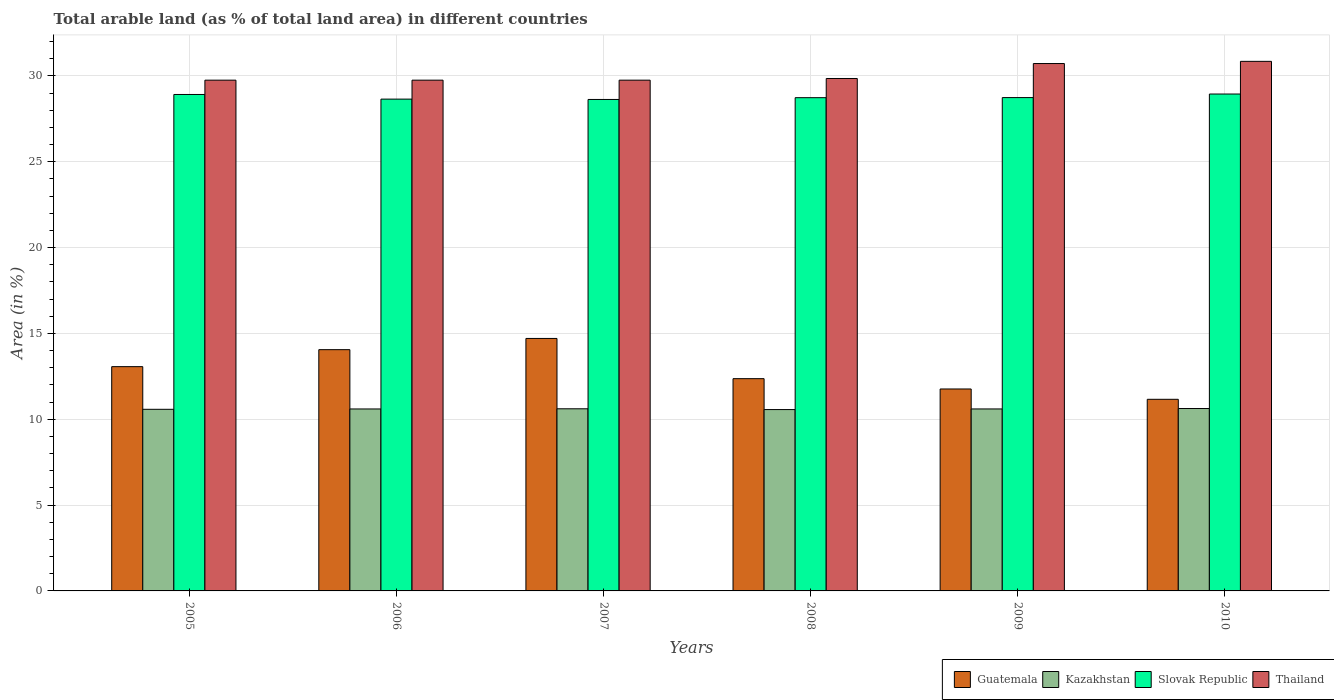Are the number of bars per tick equal to the number of legend labels?
Ensure brevity in your answer.  Yes. Are the number of bars on each tick of the X-axis equal?
Give a very brief answer. Yes. How many bars are there on the 2nd tick from the left?
Offer a terse response. 4. How many bars are there on the 4th tick from the right?
Make the answer very short. 4. What is the label of the 2nd group of bars from the left?
Your response must be concise. 2006. What is the percentage of arable land in Kazakhstan in 2008?
Your response must be concise. 10.56. Across all years, what is the maximum percentage of arable land in Thailand?
Offer a very short reply. 30.85. Across all years, what is the minimum percentage of arable land in Kazakhstan?
Keep it short and to the point. 10.56. In which year was the percentage of arable land in Kazakhstan minimum?
Ensure brevity in your answer.  2008. What is the total percentage of arable land in Slovak Republic in the graph?
Make the answer very short. 172.61. What is the difference between the percentage of arable land in Kazakhstan in 2008 and that in 2009?
Your answer should be very brief. -0.04. What is the difference between the percentage of arable land in Thailand in 2008 and the percentage of arable land in Slovak Republic in 2009?
Make the answer very short. 1.11. What is the average percentage of arable land in Slovak Republic per year?
Offer a very short reply. 28.77. In the year 2005, what is the difference between the percentage of arable land in Thailand and percentage of arable land in Kazakhstan?
Keep it short and to the point. 19.17. In how many years, is the percentage of arable land in Slovak Republic greater than 4 %?
Provide a succinct answer. 6. What is the ratio of the percentage of arable land in Thailand in 2007 to that in 2009?
Ensure brevity in your answer.  0.97. Is the difference between the percentage of arable land in Thailand in 2005 and 2007 greater than the difference between the percentage of arable land in Kazakhstan in 2005 and 2007?
Offer a very short reply. Yes. What is the difference between the highest and the second highest percentage of arable land in Kazakhstan?
Provide a short and direct response. 0.02. What is the difference between the highest and the lowest percentage of arable land in Thailand?
Provide a short and direct response. 1.1. In how many years, is the percentage of arable land in Kazakhstan greater than the average percentage of arable land in Kazakhstan taken over all years?
Give a very brief answer. 4. Is the sum of the percentage of arable land in Thailand in 2006 and 2008 greater than the maximum percentage of arable land in Slovak Republic across all years?
Provide a short and direct response. Yes. What does the 2nd bar from the left in 2007 represents?
Offer a very short reply. Kazakhstan. What does the 2nd bar from the right in 2006 represents?
Ensure brevity in your answer.  Slovak Republic. Are the values on the major ticks of Y-axis written in scientific E-notation?
Offer a very short reply. No. Does the graph contain grids?
Provide a short and direct response. Yes. Where does the legend appear in the graph?
Provide a short and direct response. Bottom right. How are the legend labels stacked?
Give a very brief answer. Horizontal. What is the title of the graph?
Give a very brief answer. Total arable land (as % of total land area) in different countries. Does "Fragile and conflict affected situations" appear as one of the legend labels in the graph?
Provide a succinct answer. No. What is the label or title of the Y-axis?
Ensure brevity in your answer.  Area (in %). What is the Area (in %) in Guatemala in 2005?
Your answer should be very brief. 13.06. What is the Area (in %) in Kazakhstan in 2005?
Offer a terse response. 10.58. What is the Area (in %) in Slovak Republic in 2005?
Offer a very short reply. 28.92. What is the Area (in %) of Thailand in 2005?
Your answer should be compact. 29.75. What is the Area (in %) in Guatemala in 2006?
Make the answer very short. 14.05. What is the Area (in %) of Kazakhstan in 2006?
Your response must be concise. 10.6. What is the Area (in %) of Slovak Republic in 2006?
Give a very brief answer. 28.65. What is the Area (in %) of Thailand in 2006?
Your answer should be compact. 29.75. What is the Area (in %) of Guatemala in 2007?
Offer a terse response. 14.71. What is the Area (in %) in Kazakhstan in 2007?
Your answer should be very brief. 10.61. What is the Area (in %) in Slovak Republic in 2007?
Your response must be concise. 28.63. What is the Area (in %) of Thailand in 2007?
Give a very brief answer. 29.75. What is the Area (in %) of Guatemala in 2008?
Make the answer very short. 12.36. What is the Area (in %) of Kazakhstan in 2008?
Ensure brevity in your answer.  10.56. What is the Area (in %) of Slovak Republic in 2008?
Give a very brief answer. 28.73. What is the Area (in %) in Thailand in 2008?
Keep it short and to the point. 29.85. What is the Area (in %) in Guatemala in 2009?
Offer a very short reply. 11.76. What is the Area (in %) of Kazakhstan in 2009?
Make the answer very short. 10.6. What is the Area (in %) of Slovak Republic in 2009?
Make the answer very short. 28.74. What is the Area (in %) of Thailand in 2009?
Offer a very short reply. 30.72. What is the Area (in %) in Guatemala in 2010?
Offer a very short reply. 11.16. What is the Area (in %) of Kazakhstan in 2010?
Give a very brief answer. 10.62. What is the Area (in %) of Slovak Republic in 2010?
Make the answer very short. 28.95. What is the Area (in %) in Thailand in 2010?
Ensure brevity in your answer.  30.85. Across all years, what is the maximum Area (in %) of Guatemala?
Make the answer very short. 14.71. Across all years, what is the maximum Area (in %) of Kazakhstan?
Keep it short and to the point. 10.62. Across all years, what is the maximum Area (in %) in Slovak Republic?
Give a very brief answer. 28.95. Across all years, what is the maximum Area (in %) in Thailand?
Provide a succinct answer. 30.85. Across all years, what is the minimum Area (in %) of Guatemala?
Offer a terse response. 11.16. Across all years, what is the minimum Area (in %) of Kazakhstan?
Provide a short and direct response. 10.56. Across all years, what is the minimum Area (in %) in Slovak Republic?
Your answer should be very brief. 28.63. Across all years, what is the minimum Area (in %) of Thailand?
Your answer should be compact. 29.75. What is the total Area (in %) of Guatemala in the graph?
Your answer should be compact. 77.11. What is the total Area (in %) in Kazakhstan in the graph?
Give a very brief answer. 63.58. What is the total Area (in %) in Slovak Republic in the graph?
Ensure brevity in your answer.  172.61. What is the total Area (in %) in Thailand in the graph?
Provide a succinct answer. 180.67. What is the difference between the Area (in %) of Guatemala in 2005 and that in 2006?
Offer a very short reply. -0.99. What is the difference between the Area (in %) in Kazakhstan in 2005 and that in 2006?
Provide a succinct answer. -0.02. What is the difference between the Area (in %) in Slovak Republic in 2005 and that in 2006?
Keep it short and to the point. 0.27. What is the difference between the Area (in %) of Guatemala in 2005 and that in 2007?
Your answer should be compact. -1.64. What is the difference between the Area (in %) of Kazakhstan in 2005 and that in 2007?
Offer a very short reply. -0.03. What is the difference between the Area (in %) of Slovak Republic in 2005 and that in 2007?
Keep it short and to the point. 0.29. What is the difference between the Area (in %) in Thailand in 2005 and that in 2007?
Ensure brevity in your answer.  0. What is the difference between the Area (in %) in Guatemala in 2005 and that in 2008?
Your answer should be very brief. 0.7. What is the difference between the Area (in %) in Kazakhstan in 2005 and that in 2008?
Provide a succinct answer. 0.02. What is the difference between the Area (in %) of Slovak Republic in 2005 and that in 2008?
Your answer should be very brief. 0.19. What is the difference between the Area (in %) of Thailand in 2005 and that in 2008?
Provide a short and direct response. -0.1. What is the difference between the Area (in %) of Guatemala in 2005 and that in 2009?
Your answer should be compact. 1.3. What is the difference between the Area (in %) in Kazakhstan in 2005 and that in 2009?
Offer a very short reply. -0.02. What is the difference between the Area (in %) in Slovak Republic in 2005 and that in 2009?
Make the answer very short. 0.18. What is the difference between the Area (in %) of Thailand in 2005 and that in 2009?
Offer a very short reply. -0.97. What is the difference between the Area (in %) of Guatemala in 2005 and that in 2010?
Provide a short and direct response. 1.9. What is the difference between the Area (in %) of Kazakhstan in 2005 and that in 2010?
Offer a very short reply. -0.04. What is the difference between the Area (in %) in Slovak Republic in 2005 and that in 2010?
Your answer should be very brief. -0.03. What is the difference between the Area (in %) of Thailand in 2005 and that in 2010?
Your response must be concise. -1.1. What is the difference between the Area (in %) in Guatemala in 2006 and that in 2007?
Make the answer very short. -0.65. What is the difference between the Area (in %) of Kazakhstan in 2006 and that in 2007?
Offer a terse response. -0.01. What is the difference between the Area (in %) of Slovak Republic in 2006 and that in 2007?
Offer a very short reply. 0.02. What is the difference between the Area (in %) of Guatemala in 2006 and that in 2008?
Your answer should be very brief. 1.69. What is the difference between the Area (in %) of Kazakhstan in 2006 and that in 2008?
Give a very brief answer. 0.04. What is the difference between the Area (in %) of Slovak Republic in 2006 and that in 2008?
Your answer should be compact. -0.08. What is the difference between the Area (in %) in Thailand in 2006 and that in 2008?
Your response must be concise. -0.1. What is the difference between the Area (in %) in Guatemala in 2006 and that in 2009?
Your response must be concise. 2.29. What is the difference between the Area (in %) of Kazakhstan in 2006 and that in 2009?
Keep it short and to the point. -0. What is the difference between the Area (in %) of Slovak Republic in 2006 and that in 2009?
Give a very brief answer. -0.09. What is the difference between the Area (in %) of Thailand in 2006 and that in 2009?
Offer a very short reply. -0.97. What is the difference between the Area (in %) in Guatemala in 2006 and that in 2010?
Ensure brevity in your answer.  2.89. What is the difference between the Area (in %) in Kazakhstan in 2006 and that in 2010?
Make the answer very short. -0.03. What is the difference between the Area (in %) of Slovak Republic in 2006 and that in 2010?
Your answer should be very brief. -0.3. What is the difference between the Area (in %) of Thailand in 2006 and that in 2010?
Keep it short and to the point. -1.1. What is the difference between the Area (in %) in Guatemala in 2007 and that in 2008?
Ensure brevity in your answer.  2.34. What is the difference between the Area (in %) in Kazakhstan in 2007 and that in 2008?
Provide a short and direct response. 0.04. What is the difference between the Area (in %) of Slovak Republic in 2007 and that in 2008?
Keep it short and to the point. -0.1. What is the difference between the Area (in %) of Thailand in 2007 and that in 2008?
Your response must be concise. -0.1. What is the difference between the Area (in %) of Guatemala in 2007 and that in 2009?
Ensure brevity in your answer.  2.94. What is the difference between the Area (in %) in Kazakhstan in 2007 and that in 2009?
Ensure brevity in your answer.  0.01. What is the difference between the Area (in %) in Slovak Republic in 2007 and that in 2009?
Provide a succinct answer. -0.11. What is the difference between the Area (in %) in Thailand in 2007 and that in 2009?
Offer a very short reply. -0.97. What is the difference between the Area (in %) of Guatemala in 2007 and that in 2010?
Offer a terse response. 3.55. What is the difference between the Area (in %) in Kazakhstan in 2007 and that in 2010?
Provide a succinct answer. -0.02. What is the difference between the Area (in %) of Slovak Republic in 2007 and that in 2010?
Provide a short and direct response. -0.32. What is the difference between the Area (in %) of Thailand in 2007 and that in 2010?
Make the answer very short. -1.1. What is the difference between the Area (in %) in Guatemala in 2008 and that in 2009?
Offer a terse response. 0.6. What is the difference between the Area (in %) of Kazakhstan in 2008 and that in 2009?
Offer a terse response. -0.04. What is the difference between the Area (in %) of Slovak Republic in 2008 and that in 2009?
Your response must be concise. -0.01. What is the difference between the Area (in %) in Thailand in 2008 and that in 2009?
Ensure brevity in your answer.  -0.87. What is the difference between the Area (in %) of Guatemala in 2008 and that in 2010?
Offer a very short reply. 1.2. What is the difference between the Area (in %) in Kazakhstan in 2008 and that in 2010?
Ensure brevity in your answer.  -0.06. What is the difference between the Area (in %) of Slovak Republic in 2008 and that in 2010?
Your answer should be very brief. -0.21. What is the difference between the Area (in %) in Thailand in 2008 and that in 2010?
Provide a succinct answer. -1. What is the difference between the Area (in %) in Guatemala in 2009 and that in 2010?
Your answer should be very brief. 0.6. What is the difference between the Area (in %) of Kazakhstan in 2009 and that in 2010?
Give a very brief answer. -0.02. What is the difference between the Area (in %) in Slovak Republic in 2009 and that in 2010?
Offer a terse response. -0.21. What is the difference between the Area (in %) of Thailand in 2009 and that in 2010?
Provide a short and direct response. -0.13. What is the difference between the Area (in %) in Guatemala in 2005 and the Area (in %) in Kazakhstan in 2006?
Ensure brevity in your answer.  2.46. What is the difference between the Area (in %) in Guatemala in 2005 and the Area (in %) in Slovak Republic in 2006?
Your response must be concise. -15.58. What is the difference between the Area (in %) in Guatemala in 2005 and the Area (in %) in Thailand in 2006?
Offer a very short reply. -16.69. What is the difference between the Area (in %) of Kazakhstan in 2005 and the Area (in %) of Slovak Republic in 2006?
Make the answer very short. -18.07. What is the difference between the Area (in %) of Kazakhstan in 2005 and the Area (in %) of Thailand in 2006?
Make the answer very short. -19.17. What is the difference between the Area (in %) of Slovak Republic in 2005 and the Area (in %) of Thailand in 2006?
Ensure brevity in your answer.  -0.83. What is the difference between the Area (in %) in Guatemala in 2005 and the Area (in %) in Kazakhstan in 2007?
Ensure brevity in your answer.  2.46. What is the difference between the Area (in %) of Guatemala in 2005 and the Area (in %) of Slovak Republic in 2007?
Ensure brevity in your answer.  -15.56. What is the difference between the Area (in %) in Guatemala in 2005 and the Area (in %) in Thailand in 2007?
Offer a very short reply. -16.69. What is the difference between the Area (in %) of Kazakhstan in 2005 and the Area (in %) of Slovak Republic in 2007?
Offer a very short reply. -18.05. What is the difference between the Area (in %) in Kazakhstan in 2005 and the Area (in %) in Thailand in 2007?
Provide a short and direct response. -19.17. What is the difference between the Area (in %) in Slovak Republic in 2005 and the Area (in %) in Thailand in 2007?
Offer a very short reply. -0.83. What is the difference between the Area (in %) in Guatemala in 2005 and the Area (in %) in Kazakhstan in 2008?
Provide a succinct answer. 2.5. What is the difference between the Area (in %) in Guatemala in 2005 and the Area (in %) in Slovak Republic in 2008?
Offer a terse response. -15.67. What is the difference between the Area (in %) of Guatemala in 2005 and the Area (in %) of Thailand in 2008?
Ensure brevity in your answer.  -16.79. What is the difference between the Area (in %) of Kazakhstan in 2005 and the Area (in %) of Slovak Republic in 2008?
Give a very brief answer. -18.15. What is the difference between the Area (in %) of Kazakhstan in 2005 and the Area (in %) of Thailand in 2008?
Your response must be concise. -19.27. What is the difference between the Area (in %) of Slovak Republic in 2005 and the Area (in %) of Thailand in 2008?
Keep it short and to the point. -0.93. What is the difference between the Area (in %) in Guatemala in 2005 and the Area (in %) in Kazakhstan in 2009?
Your response must be concise. 2.46. What is the difference between the Area (in %) in Guatemala in 2005 and the Area (in %) in Slovak Republic in 2009?
Give a very brief answer. -15.67. What is the difference between the Area (in %) of Guatemala in 2005 and the Area (in %) of Thailand in 2009?
Your answer should be very brief. -17.66. What is the difference between the Area (in %) in Kazakhstan in 2005 and the Area (in %) in Slovak Republic in 2009?
Offer a terse response. -18.16. What is the difference between the Area (in %) in Kazakhstan in 2005 and the Area (in %) in Thailand in 2009?
Keep it short and to the point. -20.14. What is the difference between the Area (in %) of Slovak Republic in 2005 and the Area (in %) of Thailand in 2009?
Offer a terse response. -1.8. What is the difference between the Area (in %) in Guatemala in 2005 and the Area (in %) in Kazakhstan in 2010?
Ensure brevity in your answer.  2.44. What is the difference between the Area (in %) in Guatemala in 2005 and the Area (in %) in Slovak Republic in 2010?
Your answer should be compact. -15.88. What is the difference between the Area (in %) in Guatemala in 2005 and the Area (in %) in Thailand in 2010?
Give a very brief answer. -17.78. What is the difference between the Area (in %) in Kazakhstan in 2005 and the Area (in %) in Slovak Republic in 2010?
Offer a very short reply. -18.37. What is the difference between the Area (in %) of Kazakhstan in 2005 and the Area (in %) of Thailand in 2010?
Provide a short and direct response. -20.27. What is the difference between the Area (in %) of Slovak Republic in 2005 and the Area (in %) of Thailand in 2010?
Your answer should be compact. -1.93. What is the difference between the Area (in %) of Guatemala in 2006 and the Area (in %) of Kazakhstan in 2007?
Provide a succinct answer. 3.44. What is the difference between the Area (in %) of Guatemala in 2006 and the Area (in %) of Slovak Republic in 2007?
Provide a succinct answer. -14.57. What is the difference between the Area (in %) in Guatemala in 2006 and the Area (in %) in Thailand in 2007?
Offer a very short reply. -15.7. What is the difference between the Area (in %) of Kazakhstan in 2006 and the Area (in %) of Slovak Republic in 2007?
Keep it short and to the point. -18.03. What is the difference between the Area (in %) in Kazakhstan in 2006 and the Area (in %) in Thailand in 2007?
Offer a terse response. -19.15. What is the difference between the Area (in %) in Slovak Republic in 2006 and the Area (in %) in Thailand in 2007?
Provide a succinct answer. -1.1. What is the difference between the Area (in %) in Guatemala in 2006 and the Area (in %) in Kazakhstan in 2008?
Give a very brief answer. 3.49. What is the difference between the Area (in %) of Guatemala in 2006 and the Area (in %) of Slovak Republic in 2008?
Ensure brevity in your answer.  -14.68. What is the difference between the Area (in %) of Guatemala in 2006 and the Area (in %) of Thailand in 2008?
Offer a terse response. -15.8. What is the difference between the Area (in %) in Kazakhstan in 2006 and the Area (in %) in Slovak Republic in 2008?
Keep it short and to the point. -18.13. What is the difference between the Area (in %) in Kazakhstan in 2006 and the Area (in %) in Thailand in 2008?
Provide a succinct answer. -19.25. What is the difference between the Area (in %) of Slovak Republic in 2006 and the Area (in %) of Thailand in 2008?
Provide a succinct answer. -1.2. What is the difference between the Area (in %) in Guatemala in 2006 and the Area (in %) in Kazakhstan in 2009?
Offer a terse response. 3.45. What is the difference between the Area (in %) in Guatemala in 2006 and the Area (in %) in Slovak Republic in 2009?
Provide a succinct answer. -14.68. What is the difference between the Area (in %) in Guatemala in 2006 and the Area (in %) in Thailand in 2009?
Your response must be concise. -16.67. What is the difference between the Area (in %) in Kazakhstan in 2006 and the Area (in %) in Slovak Republic in 2009?
Ensure brevity in your answer.  -18.14. What is the difference between the Area (in %) of Kazakhstan in 2006 and the Area (in %) of Thailand in 2009?
Keep it short and to the point. -20.12. What is the difference between the Area (in %) in Slovak Republic in 2006 and the Area (in %) in Thailand in 2009?
Keep it short and to the point. -2.07. What is the difference between the Area (in %) of Guatemala in 2006 and the Area (in %) of Kazakhstan in 2010?
Make the answer very short. 3.43. What is the difference between the Area (in %) of Guatemala in 2006 and the Area (in %) of Slovak Republic in 2010?
Keep it short and to the point. -14.89. What is the difference between the Area (in %) of Guatemala in 2006 and the Area (in %) of Thailand in 2010?
Keep it short and to the point. -16.79. What is the difference between the Area (in %) of Kazakhstan in 2006 and the Area (in %) of Slovak Republic in 2010?
Keep it short and to the point. -18.35. What is the difference between the Area (in %) of Kazakhstan in 2006 and the Area (in %) of Thailand in 2010?
Offer a terse response. -20.25. What is the difference between the Area (in %) in Slovak Republic in 2006 and the Area (in %) in Thailand in 2010?
Give a very brief answer. -2.2. What is the difference between the Area (in %) of Guatemala in 2007 and the Area (in %) of Kazakhstan in 2008?
Provide a succinct answer. 4.14. What is the difference between the Area (in %) in Guatemala in 2007 and the Area (in %) in Slovak Republic in 2008?
Your answer should be compact. -14.02. What is the difference between the Area (in %) in Guatemala in 2007 and the Area (in %) in Thailand in 2008?
Your answer should be compact. -15.14. What is the difference between the Area (in %) in Kazakhstan in 2007 and the Area (in %) in Slovak Republic in 2008?
Make the answer very short. -18.12. What is the difference between the Area (in %) in Kazakhstan in 2007 and the Area (in %) in Thailand in 2008?
Give a very brief answer. -19.24. What is the difference between the Area (in %) in Slovak Republic in 2007 and the Area (in %) in Thailand in 2008?
Ensure brevity in your answer.  -1.22. What is the difference between the Area (in %) of Guatemala in 2007 and the Area (in %) of Kazakhstan in 2009?
Provide a short and direct response. 4.11. What is the difference between the Area (in %) in Guatemala in 2007 and the Area (in %) in Slovak Republic in 2009?
Your answer should be compact. -14.03. What is the difference between the Area (in %) of Guatemala in 2007 and the Area (in %) of Thailand in 2009?
Offer a very short reply. -16.01. What is the difference between the Area (in %) in Kazakhstan in 2007 and the Area (in %) in Slovak Republic in 2009?
Your answer should be very brief. -18.13. What is the difference between the Area (in %) of Kazakhstan in 2007 and the Area (in %) of Thailand in 2009?
Provide a short and direct response. -20.11. What is the difference between the Area (in %) in Slovak Republic in 2007 and the Area (in %) in Thailand in 2009?
Keep it short and to the point. -2.09. What is the difference between the Area (in %) in Guatemala in 2007 and the Area (in %) in Kazakhstan in 2010?
Ensure brevity in your answer.  4.08. What is the difference between the Area (in %) in Guatemala in 2007 and the Area (in %) in Slovak Republic in 2010?
Ensure brevity in your answer.  -14.24. What is the difference between the Area (in %) of Guatemala in 2007 and the Area (in %) of Thailand in 2010?
Provide a short and direct response. -16.14. What is the difference between the Area (in %) in Kazakhstan in 2007 and the Area (in %) in Slovak Republic in 2010?
Your answer should be very brief. -18.34. What is the difference between the Area (in %) in Kazakhstan in 2007 and the Area (in %) in Thailand in 2010?
Keep it short and to the point. -20.24. What is the difference between the Area (in %) of Slovak Republic in 2007 and the Area (in %) of Thailand in 2010?
Provide a succinct answer. -2.22. What is the difference between the Area (in %) of Guatemala in 2008 and the Area (in %) of Kazakhstan in 2009?
Give a very brief answer. 1.76. What is the difference between the Area (in %) in Guatemala in 2008 and the Area (in %) in Slovak Republic in 2009?
Make the answer very short. -16.37. What is the difference between the Area (in %) of Guatemala in 2008 and the Area (in %) of Thailand in 2009?
Your response must be concise. -18.36. What is the difference between the Area (in %) in Kazakhstan in 2008 and the Area (in %) in Slovak Republic in 2009?
Provide a short and direct response. -18.17. What is the difference between the Area (in %) in Kazakhstan in 2008 and the Area (in %) in Thailand in 2009?
Give a very brief answer. -20.16. What is the difference between the Area (in %) in Slovak Republic in 2008 and the Area (in %) in Thailand in 2009?
Your answer should be very brief. -1.99. What is the difference between the Area (in %) of Guatemala in 2008 and the Area (in %) of Kazakhstan in 2010?
Your answer should be compact. 1.74. What is the difference between the Area (in %) in Guatemala in 2008 and the Area (in %) in Slovak Republic in 2010?
Offer a very short reply. -16.58. What is the difference between the Area (in %) of Guatemala in 2008 and the Area (in %) of Thailand in 2010?
Ensure brevity in your answer.  -18.48. What is the difference between the Area (in %) in Kazakhstan in 2008 and the Area (in %) in Slovak Republic in 2010?
Your answer should be compact. -18.38. What is the difference between the Area (in %) of Kazakhstan in 2008 and the Area (in %) of Thailand in 2010?
Your answer should be compact. -20.28. What is the difference between the Area (in %) of Slovak Republic in 2008 and the Area (in %) of Thailand in 2010?
Your answer should be compact. -2.12. What is the difference between the Area (in %) of Guatemala in 2009 and the Area (in %) of Kazakhstan in 2010?
Offer a very short reply. 1.14. What is the difference between the Area (in %) in Guatemala in 2009 and the Area (in %) in Slovak Republic in 2010?
Offer a terse response. -17.18. What is the difference between the Area (in %) of Guatemala in 2009 and the Area (in %) of Thailand in 2010?
Offer a terse response. -19.09. What is the difference between the Area (in %) in Kazakhstan in 2009 and the Area (in %) in Slovak Republic in 2010?
Provide a short and direct response. -18.34. What is the difference between the Area (in %) in Kazakhstan in 2009 and the Area (in %) in Thailand in 2010?
Offer a terse response. -20.25. What is the difference between the Area (in %) in Slovak Republic in 2009 and the Area (in %) in Thailand in 2010?
Offer a terse response. -2.11. What is the average Area (in %) of Guatemala per year?
Keep it short and to the point. 12.85. What is the average Area (in %) of Kazakhstan per year?
Give a very brief answer. 10.6. What is the average Area (in %) of Slovak Republic per year?
Your response must be concise. 28.77. What is the average Area (in %) in Thailand per year?
Your response must be concise. 30.11. In the year 2005, what is the difference between the Area (in %) of Guatemala and Area (in %) of Kazakhstan?
Give a very brief answer. 2.48. In the year 2005, what is the difference between the Area (in %) of Guatemala and Area (in %) of Slovak Republic?
Provide a succinct answer. -15.85. In the year 2005, what is the difference between the Area (in %) of Guatemala and Area (in %) of Thailand?
Offer a terse response. -16.69. In the year 2005, what is the difference between the Area (in %) of Kazakhstan and Area (in %) of Slovak Republic?
Your answer should be very brief. -18.34. In the year 2005, what is the difference between the Area (in %) in Kazakhstan and Area (in %) in Thailand?
Keep it short and to the point. -19.17. In the year 2005, what is the difference between the Area (in %) of Slovak Republic and Area (in %) of Thailand?
Ensure brevity in your answer.  -0.83. In the year 2006, what is the difference between the Area (in %) in Guatemala and Area (in %) in Kazakhstan?
Your answer should be very brief. 3.45. In the year 2006, what is the difference between the Area (in %) in Guatemala and Area (in %) in Slovak Republic?
Offer a terse response. -14.59. In the year 2006, what is the difference between the Area (in %) in Guatemala and Area (in %) in Thailand?
Offer a very short reply. -15.7. In the year 2006, what is the difference between the Area (in %) in Kazakhstan and Area (in %) in Slovak Republic?
Ensure brevity in your answer.  -18.05. In the year 2006, what is the difference between the Area (in %) in Kazakhstan and Area (in %) in Thailand?
Offer a very short reply. -19.15. In the year 2006, what is the difference between the Area (in %) of Slovak Republic and Area (in %) of Thailand?
Give a very brief answer. -1.1. In the year 2007, what is the difference between the Area (in %) of Guatemala and Area (in %) of Kazakhstan?
Keep it short and to the point. 4.1. In the year 2007, what is the difference between the Area (in %) in Guatemala and Area (in %) in Slovak Republic?
Offer a terse response. -13.92. In the year 2007, what is the difference between the Area (in %) in Guatemala and Area (in %) in Thailand?
Keep it short and to the point. -15.04. In the year 2007, what is the difference between the Area (in %) in Kazakhstan and Area (in %) in Slovak Republic?
Your answer should be very brief. -18.02. In the year 2007, what is the difference between the Area (in %) of Kazakhstan and Area (in %) of Thailand?
Offer a terse response. -19.14. In the year 2007, what is the difference between the Area (in %) in Slovak Republic and Area (in %) in Thailand?
Your response must be concise. -1.12. In the year 2008, what is the difference between the Area (in %) of Guatemala and Area (in %) of Kazakhstan?
Keep it short and to the point. 1.8. In the year 2008, what is the difference between the Area (in %) in Guatemala and Area (in %) in Slovak Republic?
Your answer should be compact. -16.37. In the year 2008, what is the difference between the Area (in %) in Guatemala and Area (in %) in Thailand?
Provide a short and direct response. -17.49. In the year 2008, what is the difference between the Area (in %) of Kazakhstan and Area (in %) of Slovak Republic?
Offer a very short reply. -18.17. In the year 2008, what is the difference between the Area (in %) in Kazakhstan and Area (in %) in Thailand?
Keep it short and to the point. -19.29. In the year 2008, what is the difference between the Area (in %) of Slovak Republic and Area (in %) of Thailand?
Provide a succinct answer. -1.12. In the year 2009, what is the difference between the Area (in %) of Guatemala and Area (in %) of Kazakhstan?
Keep it short and to the point. 1.16. In the year 2009, what is the difference between the Area (in %) in Guatemala and Area (in %) in Slovak Republic?
Your response must be concise. -16.97. In the year 2009, what is the difference between the Area (in %) of Guatemala and Area (in %) of Thailand?
Make the answer very short. -18.96. In the year 2009, what is the difference between the Area (in %) in Kazakhstan and Area (in %) in Slovak Republic?
Provide a succinct answer. -18.14. In the year 2009, what is the difference between the Area (in %) in Kazakhstan and Area (in %) in Thailand?
Provide a succinct answer. -20.12. In the year 2009, what is the difference between the Area (in %) in Slovak Republic and Area (in %) in Thailand?
Make the answer very short. -1.98. In the year 2010, what is the difference between the Area (in %) in Guatemala and Area (in %) in Kazakhstan?
Ensure brevity in your answer.  0.54. In the year 2010, what is the difference between the Area (in %) in Guatemala and Area (in %) in Slovak Republic?
Offer a very short reply. -17.78. In the year 2010, what is the difference between the Area (in %) in Guatemala and Area (in %) in Thailand?
Ensure brevity in your answer.  -19.69. In the year 2010, what is the difference between the Area (in %) in Kazakhstan and Area (in %) in Slovak Republic?
Your response must be concise. -18.32. In the year 2010, what is the difference between the Area (in %) in Kazakhstan and Area (in %) in Thailand?
Ensure brevity in your answer.  -20.22. In the year 2010, what is the difference between the Area (in %) of Slovak Republic and Area (in %) of Thailand?
Make the answer very short. -1.9. What is the ratio of the Area (in %) in Guatemala in 2005 to that in 2006?
Provide a short and direct response. 0.93. What is the ratio of the Area (in %) of Slovak Republic in 2005 to that in 2006?
Provide a short and direct response. 1.01. What is the ratio of the Area (in %) in Thailand in 2005 to that in 2006?
Offer a terse response. 1. What is the ratio of the Area (in %) in Guatemala in 2005 to that in 2007?
Offer a terse response. 0.89. What is the ratio of the Area (in %) of Slovak Republic in 2005 to that in 2007?
Your answer should be very brief. 1.01. What is the ratio of the Area (in %) in Thailand in 2005 to that in 2007?
Keep it short and to the point. 1. What is the ratio of the Area (in %) in Guatemala in 2005 to that in 2008?
Provide a succinct answer. 1.06. What is the ratio of the Area (in %) in Slovak Republic in 2005 to that in 2008?
Provide a succinct answer. 1.01. What is the ratio of the Area (in %) in Thailand in 2005 to that in 2008?
Provide a succinct answer. 1. What is the ratio of the Area (in %) of Guatemala in 2005 to that in 2009?
Ensure brevity in your answer.  1.11. What is the ratio of the Area (in %) of Thailand in 2005 to that in 2009?
Offer a terse response. 0.97. What is the ratio of the Area (in %) in Guatemala in 2005 to that in 2010?
Provide a succinct answer. 1.17. What is the ratio of the Area (in %) of Kazakhstan in 2005 to that in 2010?
Your answer should be compact. 1. What is the ratio of the Area (in %) in Slovak Republic in 2005 to that in 2010?
Make the answer very short. 1. What is the ratio of the Area (in %) in Thailand in 2005 to that in 2010?
Offer a very short reply. 0.96. What is the ratio of the Area (in %) in Guatemala in 2006 to that in 2007?
Offer a terse response. 0.96. What is the ratio of the Area (in %) of Kazakhstan in 2006 to that in 2007?
Ensure brevity in your answer.  1. What is the ratio of the Area (in %) of Slovak Republic in 2006 to that in 2007?
Provide a short and direct response. 1. What is the ratio of the Area (in %) in Guatemala in 2006 to that in 2008?
Give a very brief answer. 1.14. What is the ratio of the Area (in %) of Thailand in 2006 to that in 2008?
Give a very brief answer. 1. What is the ratio of the Area (in %) of Guatemala in 2006 to that in 2009?
Make the answer very short. 1.19. What is the ratio of the Area (in %) of Kazakhstan in 2006 to that in 2009?
Offer a very short reply. 1. What is the ratio of the Area (in %) of Slovak Republic in 2006 to that in 2009?
Make the answer very short. 1. What is the ratio of the Area (in %) in Thailand in 2006 to that in 2009?
Your response must be concise. 0.97. What is the ratio of the Area (in %) of Guatemala in 2006 to that in 2010?
Keep it short and to the point. 1.26. What is the ratio of the Area (in %) in Kazakhstan in 2006 to that in 2010?
Make the answer very short. 1. What is the ratio of the Area (in %) of Thailand in 2006 to that in 2010?
Provide a succinct answer. 0.96. What is the ratio of the Area (in %) of Guatemala in 2007 to that in 2008?
Offer a very short reply. 1.19. What is the ratio of the Area (in %) of Kazakhstan in 2007 to that in 2008?
Make the answer very short. 1. What is the ratio of the Area (in %) of Thailand in 2007 to that in 2008?
Provide a short and direct response. 1. What is the ratio of the Area (in %) of Guatemala in 2007 to that in 2009?
Make the answer very short. 1.25. What is the ratio of the Area (in %) in Kazakhstan in 2007 to that in 2009?
Give a very brief answer. 1. What is the ratio of the Area (in %) in Thailand in 2007 to that in 2009?
Offer a terse response. 0.97. What is the ratio of the Area (in %) in Guatemala in 2007 to that in 2010?
Offer a very short reply. 1.32. What is the ratio of the Area (in %) of Thailand in 2007 to that in 2010?
Your answer should be compact. 0.96. What is the ratio of the Area (in %) of Guatemala in 2008 to that in 2009?
Offer a very short reply. 1.05. What is the ratio of the Area (in %) of Thailand in 2008 to that in 2009?
Your answer should be compact. 0.97. What is the ratio of the Area (in %) in Guatemala in 2008 to that in 2010?
Ensure brevity in your answer.  1.11. What is the ratio of the Area (in %) in Thailand in 2008 to that in 2010?
Your response must be concise. 0.97. What is the ratio of the Area (in %) in Guatemala in 2009 to that in 2010?
Your response must be concise. 1.05. What is the ratio of the Area (in %) of Thailand in 2009 to that in 2010?
Make the answer very short. 1. What is the difference between the highest and the second highest Area (in %) of Guatemala?
Ensure brevity in your answer.  0.65. What is the difference between the highest and the second highest Area (in %) of Kazakhstan?
Provide a succinct answer. 0.02. What is the difference between the highest and the second highest Area (in %) of Slovak Republic?
Keep it short and to the point. 0.03. What is the difference between the highest and the second highest Area (in %) of Thailand?
Provide a succinct answer. 0.13. What is the difference between the highest and the lowest Area (in %) of Guatemala?
Provide a succinct answer. 3.55. What is the difference between the highest and the lowest Area (in %) in Kazakhstan?
Your answer should be compact. 0.06. What is the difference between the highest and the lowest Area (in %) in Slovak Republic?
Your answer should be compact. 0.32. What is the difference between the highest and the lowest Area (in %) in Thailand?
Ensure brevity in your answer.  1.1. 